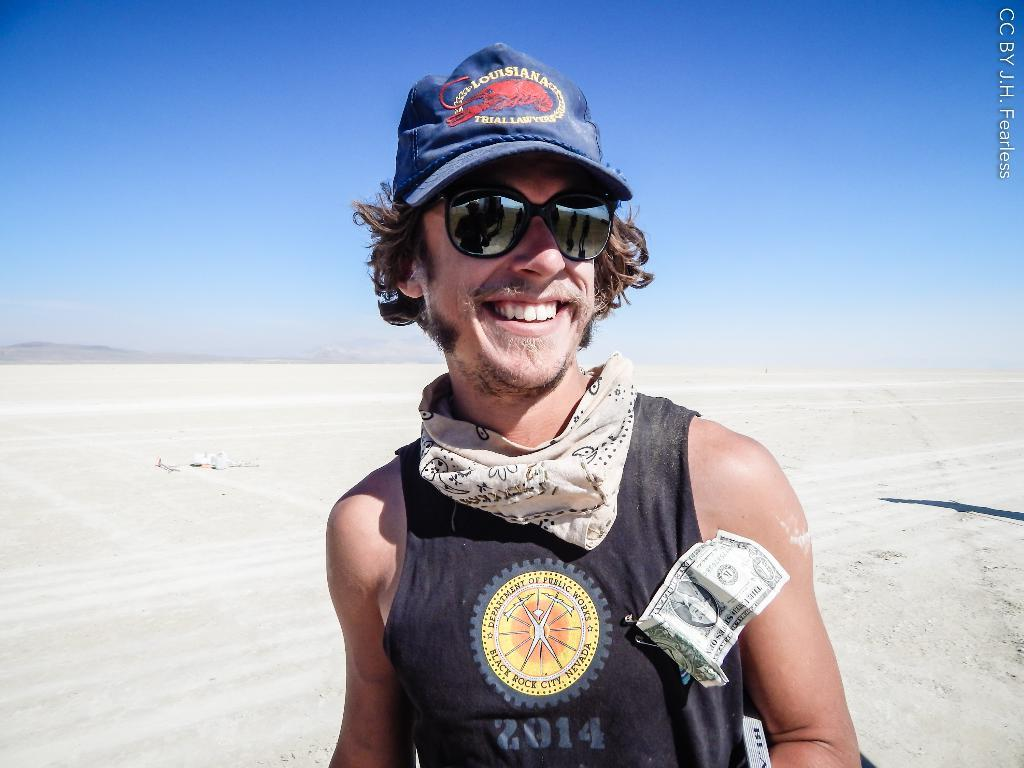What is the person in the image wearing on their face? The person in the image is wearing goggles. What type of headwear is the person wearing? The person in the image is wearing a cap. What expression does the person have in the image? The person in the image is smiling. What type of valuable item can be seen in the image? There is currency visible in the image. What is present in the background of the image? The background of the image includes a soul. What color is the sky in the image? The sky in the image is blue. Is there any indication of a watermark in the image? Yes, there is a watermark in the image. What type of collar is the cat wearing in the image? There is no cat present in the image, so there is no collar to describe. What advice does the manager give to the person in the image? There is no manager present in the image, so no advice can be given. 